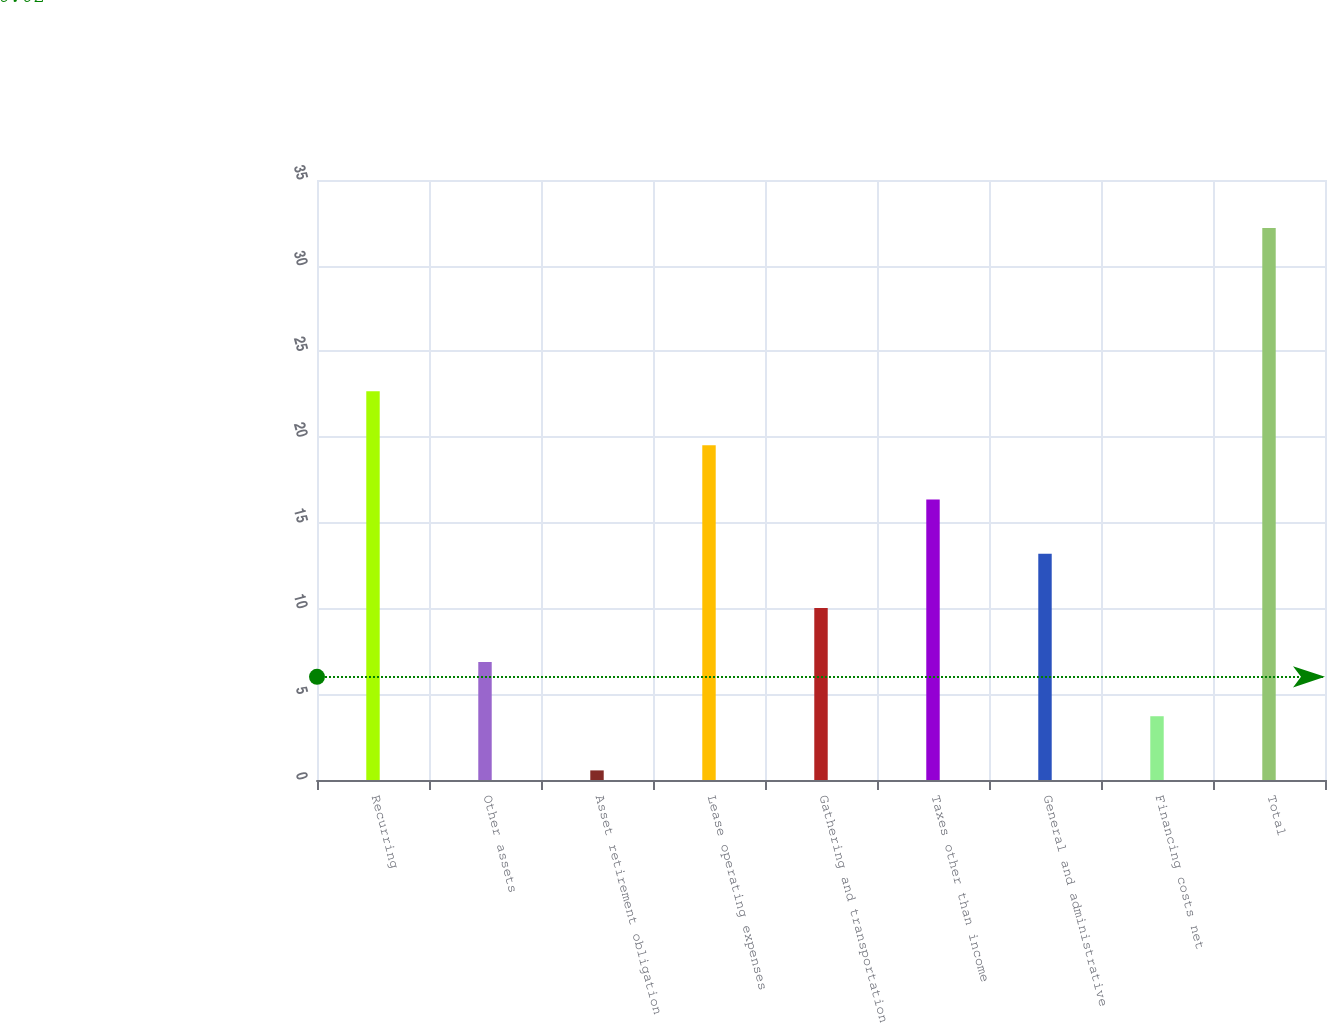Convert chart to OTSL. <chart><loc_0><loc_0><loc_500><loc_500><bar_chart><fcel>Recurring<fcel>Other assets<fcel>Asset retirement obligation<fcel>Lease operating expenses<fcel>Gathering and transportation<fcel>Taxes other than income<fcel>General and administrative<fcel>Financing costs net<fcel>Total<nl><fcel>22.68<fcel>6.88<fcel>0.56<fcel>19.52<fcel>10.04<fcel>16.36<fcel>13.2<fcel>3.72<fcel>32.2<nl></chart> 